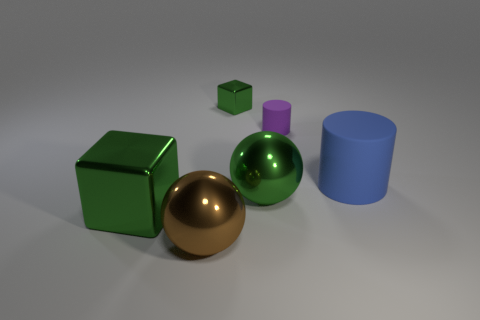Add 3 blue balls. How many objects exist? 9 Subtract all purple cylinders. How many cylinders are left? 1 Subtract all cylinders. How many objects are left? 4 Subtract 2 balls. How many balls are left? 0 Subtract all purple blocks. Subtract all green balls. How many blocks are left? 2 Subtract all purple spheres. How many gray cubes are left? 0 Subtract all big rubber cylinders. Subtract all large green metallic blocks. How many objects are left? 4 Add 5 blue rubber things. How many blue rubber things are left? 6 Add 2 balls. How many balls exist? 4 Subtract 0 gray blocks. How many objects are left? 6 